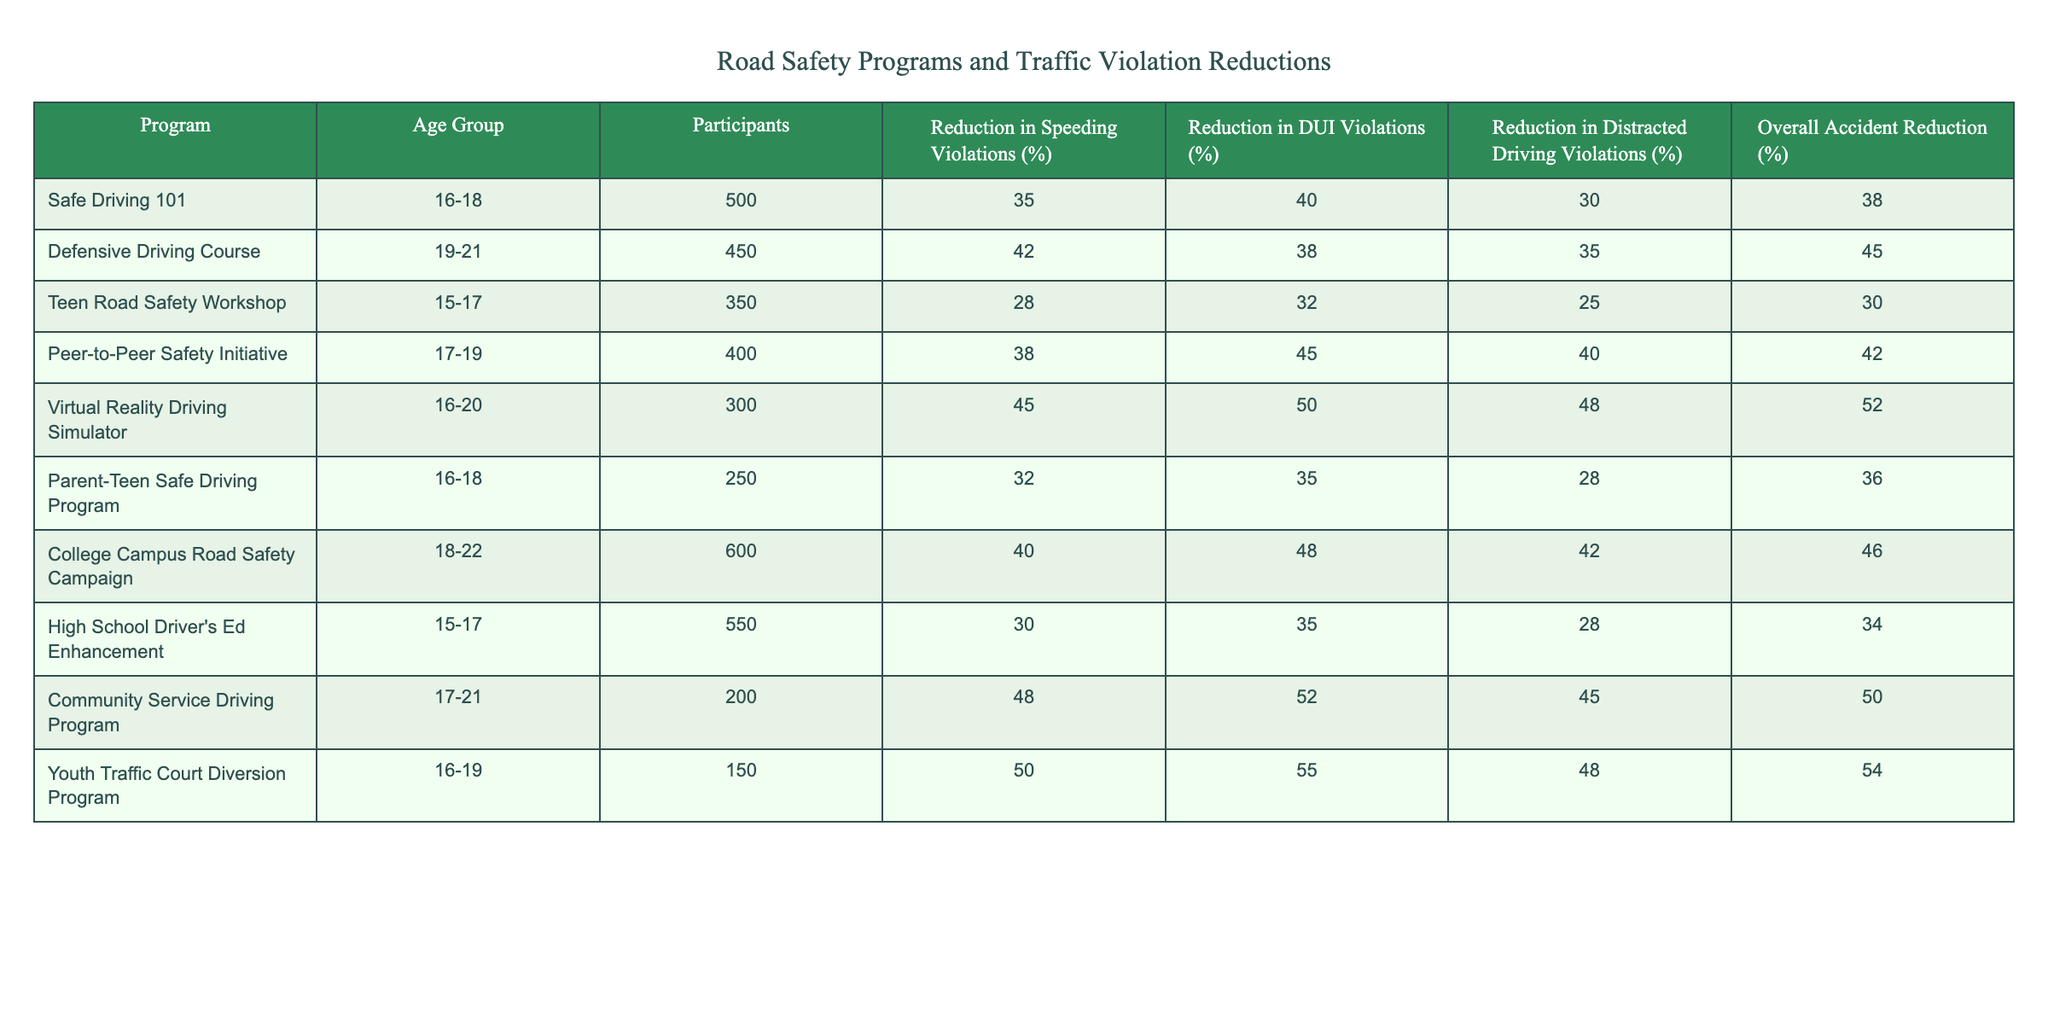What is the maximum reduction in DUI violations among these programs? Referring to the table, the maximum percentage reduction in DUI violations is found in the "Youth Traffic Court Diversion Program," which has a reduction of 55%.
Answer: 55% Which program shows the lowest reduction in distracted driving violations? The "Teen Road Safety Workshop" has the lowest reduction in distracted driving violations at 25%, as seen in the table.
Answer: 25% What is the average reduction in speeding violations across all programs? To find the average reduction, sum the reductions: 35 + 42 + 28 + 38 + 45 + 32 + 40 + 30 + 48 + 50 = 388. There are 10 programs, so 388 / 10 = 38.8% average reduction.
Answer: 38.8% Does the "Virtual Reality Driving Simulator" have a higher reduction in distracted driving violations compared to the "Parent-Teen Safe Driving Program"? The "Virtual Reality Driving Simulator" has 48% reduction while the "Parent-Teen Safe Driving Program" has 28%. Therefore, the first program shows a higher reduction.
Answer: Yes What is the overall accident reduction percentage for the "Community Service Driving Program"? The "Community Service Driving Program" has an overall accident reduction percentage of 50%, as listed in the table.
Answer: 50% Which age group participated in the program that had the largest overall accident reduction? The program with the largest overall accident reduction is the "Youth Traffic Court Diversion Program," which had an overall reduction of 54%. The age group for this program is 16-19 years old.
Answer: 16-19 Find the difference in reduction of speeding violations between the "Defensive Driving Course" and "Peer-to-Peer Safety Initiative." The "Defensive Driving Course" has a 42% reduction and the "Peer-to-Peer Safety Initiative" has a 38% reduction. The difference is 42 - 38 = 4%.
Answer: 4% Identify the program with the most participants and its overall accident reduction percentage. The "College Campus Road Safety Campaign" has the most participants at 600 and an overall accident reduction percentage of 46%, as seen in the table.
Answer: 46% Which program has a higher reduction in speeding violations, "Safe Driving 101" or "Parent-Teen Safe Driving Program"? "Safe Driving 101" has a reduction of 35% while "Parent-Teen Safe Driving Program" has 32%. Therefore, "Safe Driving 101" has a higher reduction.
Answer: Safe Driving 101 What is the sum of the reductions in speeding violations for all programs? To find the sum, add the reductions: 35 + 42 + 28 + 38 + 45 + 32 + 40 + 30 + 48 + 50 = 388.
Answer: 388 